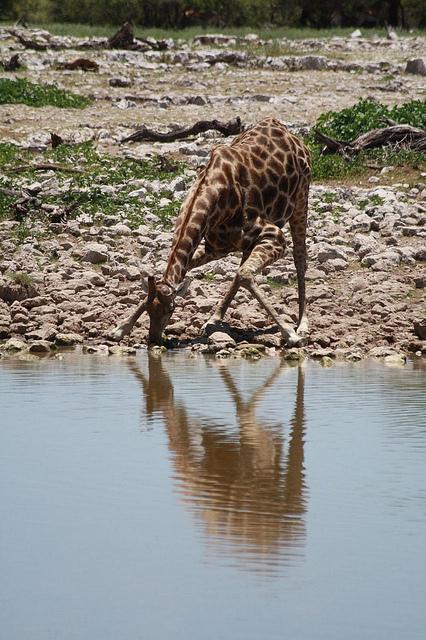What is the animal doing?
Short answer required. Drinking. Where is this animal from?
Short answer required. Africa. Is the water muddy?
Quick response, please. Yes. Is this animal in the jungle?
Concise answer only. Yes. 